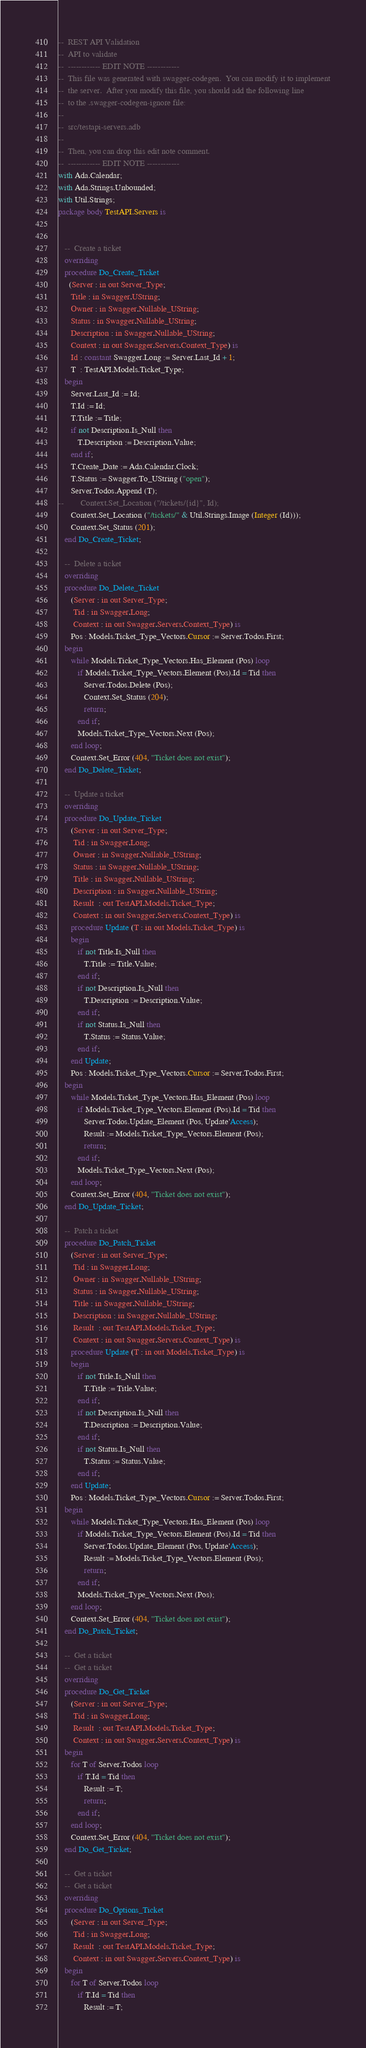Convert code to text. <code><loc_0><loc_0><loc_500><loc_500><_Ada_>--  REST API Validation
--  API to validate
--  ------------ EDIT NOTE ------------
--  This file was generated with swagger-codegen.  You can modify it to implement
--  the server.  After you modify this file, you should add the following line
--  to the .swagger-codegen-ignore file:
--
--  src/testapi-servers.adb
--
--  Then, you can drop this edit note comment.
--  ------------ EDIT NOTE ------------
with Ada.Calendar;
with Ada.Strings.Unbounded;
with Util.Strings;
package body TestAPI.Servers is


   --  Create a ticket
   overriding
   procedure Do_Create_Ticket
     (Server : in out Server_Type;
      Title : in Swagger.UString;
      Owner : in Swagger.Nullable_UString;
      Status : in Swagger.Nullable_UString;
      Description : in Swagger.Nullable_UString;
      Context : in out Swagger.Servers.Context_Type) is
      Id : constant Swagger.Long := Server.Last_Id + 1;
      T  : TestAPI.Models.Ticket_Type;
   begin
      Server.Last_Id := Id;
      T.Id := Id;
      T.Title := Title;
      if not Description.Is_Null then
         T.Description := Description.Value;
      end if;
      T.Create_Date := Ada.Calendar.Clock;
      T.Status := Swagger.To_UString ("open");
      Server.Todos.Append (T);
--        Context.Set_Location ("/tickets/{id}", Id);
      Context.Set_Location ("/tickets/" & Util.Strings.Image (Integer (Id)));
      Context.Set_Status (201);
   end Do_Create_Ticket;

   --  Delete a ticket
   overriding
   procedure Do_Delete_Ticket
      (Server : in out Server_Type;
       Tid : in Swagger.Long;
       Context : in out Swagger.Servers.Context_Type) is
      Pos : Models.Ticket_Type_Vectors.Cursor := Server.Todos.First;
   begin
      while Models.Ticket_Type_Vectors.Has_Element (Pos) loop
         if Models.Ticket_Type_Vectors.Element (Pos).Id = Tid then
            Server.Todos.Delete (Pos);
            Context.Set_Status (204);
            return;
         end if;
         Models.Ticket_Type_Vectors.Next (Pos);
      end loop;
      Context.Set_Error (404, "Ticket does not exist");
   end Do_Delete_Ticket;

   --  Update a ticket
   overriding
   procedure Do_Update_Ticket
      (Server : in out Server_Type;
       Tid : in Swagger.Long;
       Owner : in Swagger.Nullable_UString;
       Status : in Swagger.Nullable_UString;
       Title : in Swagger.Nullable_UString;
       Description : in Swagger.Nullable_UString;
       Result  : out TestAPI.Models.Ticket_Type;
       Context : in out Swagger.Servers.Context_Type) is
      procedure Update (T : in out Models.Ticket_Type) is
      begin
         if not Title.Is_Null then
            T.Title := Title.Value;
         end if;
         if not Description.Is_Null then
            T.Description := Description.Value;
         end if;
         if not Status.Is_Null then
            T.Status := Status.Value;
         end if;
      end Update;
      Pos : Models.Ticket_Type_Vectors.Cursor := Server.Todos.First;
   begin
      while Models.Ticket_Type_Vectors.Has_Element (Pos) loop
         if Models.Ticket_Type_Vectors.Element (Pos).Id = Tid then
            Server.Todos.Update_Element (Pos, Update'Access);
            Result := Models.Ticket_Type_Vectors.Element (Pos);
            return;
         end if;
         Models.Ticket_Type_Vectors.Next (Pos);
      end loop;
      Context.Set_Error (404, "Ticket does not exist");
   end Do_Update_Ticket;

   --  Patch a ticket
   procedure Do_Patch_Ticket
      (Server : in out Server_Type;
       Tid : in Swagger.Long;
       Owner : in Swagger.Nullable_UString;
       Status : in Swagger.Nullable_UString;
       Title : in Swagger.Nullable_UString;
       Description : in Swagger.Nullable_UString;
       Result  : out TestAPI.Models.Ticket_Type;
       Context : in out Swagger.Servers.Context_Type) is
      procedure Update (T : in out Models.Ticket_Type) is
      begin
         if not Title.Is_Null then
            T.Title := Title.Value;
         end if;
         if not Description.Is_Null then
            T.Description := Description.Value;
         end if;
         if not Status.Is_Null then
            T.Status := Status.Value;
         end if;
      end Update;
      Pos : Models.Ticket_Type_Vectors.Cursor := Server.Todos.First;
   begin
      while Models.Ticket_Type_Vectors.Has_Element (Pos) loop
         if Models.Ticket_Type_Vectors.Element (Pos).Id = Tid then
            Server.Todos.Update_Element (Pos, Update'Access);
            Result := Models.Ticket_Type_Vectors.Element (Pos);
            return;
         end if;
         Models.Ticket_Type_Vectors.Next (Pos);
      end loop;
      Context.Set_Error (404, "Ticket does not exist");
   end Do_Patch_Ticket;

   --  Get a ticket
   --  Get a ticket
   overriding
   procedure Do_Get_Ticket
      (Server : in out Server_Type;
       Tid : in Swagger.Long;
       Result  : out TestAPI.Models.Ticket_Type;
       Context : in out Swagger.Servers.Context_Type) is
   begin
      for T of Server.Todos loop
         if T.Id = Tid then
            Result := T;
            return;
         end if;
      end loop;
      Context.Set_Error (404, "Ticket does not exist");
   end Do_Get_Ticket;

   --  Get a ticket
   --  Get a ticket
   overriding
   procedure Do_Options_Ticket
      (Server : in out Server_Type;
       Tid : in Swagger.Long;
       Result  : out TestAPI.Models.Ticket_Type;
       Context : in out Swagger.Servers.Context_Type) is
   begin
      for T of Server.Todos loop
         if T.Id = Tid then
            Result := T;</code> 